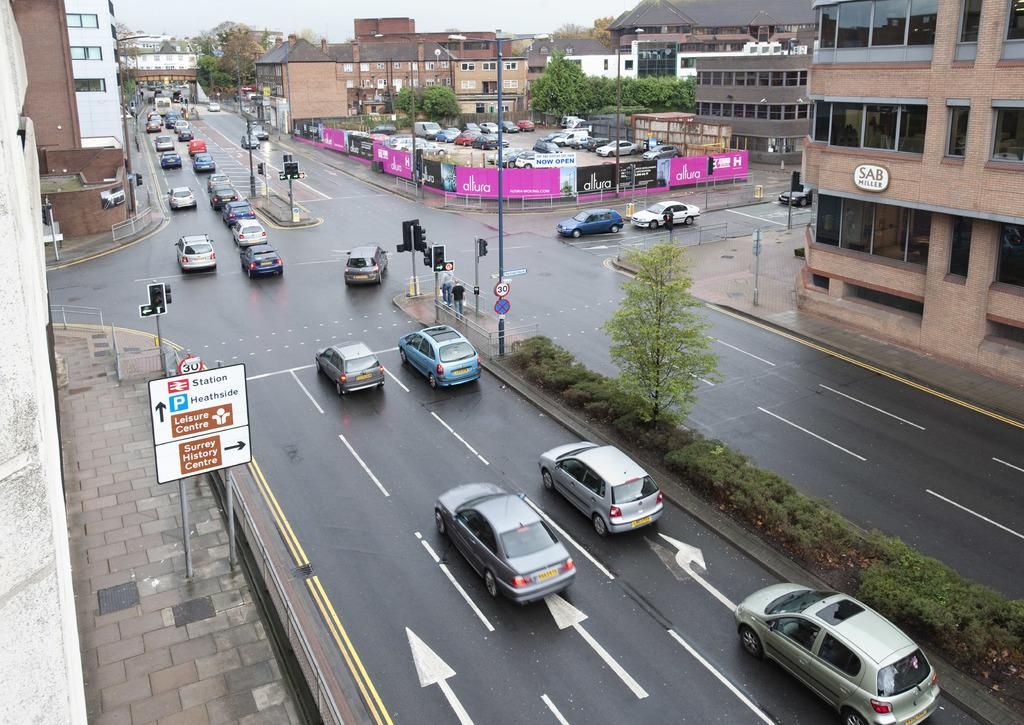What types of objects can be seen on the road in the image? There are vehicles on the road in the image. What type of natural vegetation is visible in the image? There are trees visible in the image. What type of man-made structures can be seen in the image? There are buildings visible in the image. Can you see any roses growing on the side of the road in the image? There are no roses visible in the image; only trees and buildings can be seen. What color crayon is being used to draw on the buildings in the image? There is no crayon present in the image, and therefore no such drawing activity can be observed. 